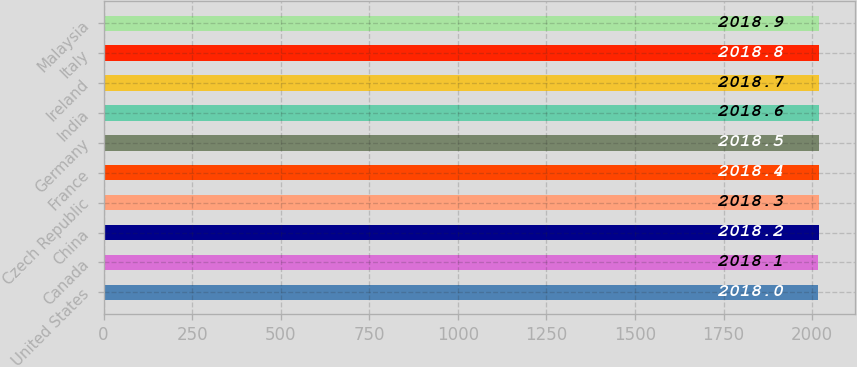Convert chart. <chart><loc_0><loc_0><loc_500><loc_500><bar_chart><fcel>United States<fcel>Canada<fcel>China<fcel>Czech Republic<fcel>France<fcel>Germany<fcel>India<fcel>Ireland<fcel>Italy<fcel>Malaysia<nl><fcel>2018<fcel>2018.1<fcel>2018.2<fcel>2018.3<fcel>2018.4<fcel>2018.5<fcel>2018.6<fcel>2018.7<fcel>2018.8<fcel>2018.9<nl></chart> 